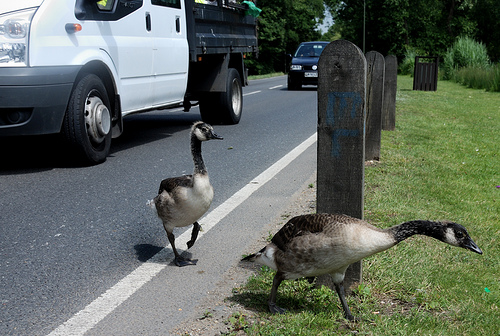<image>
Is there a goose to the right of the post? No. The goose is not to the right of the post. The horizontal positioning shows a different relationship. 